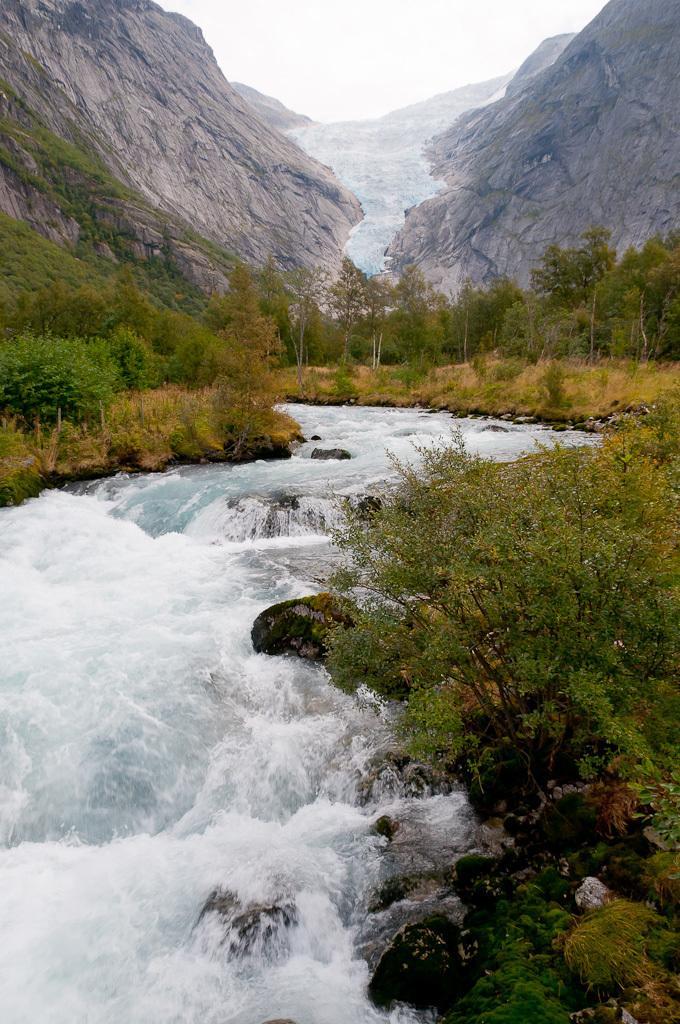Please provide a concise description of this image. This picture consists of valley in the image, there is greenery and mountains in the image. 